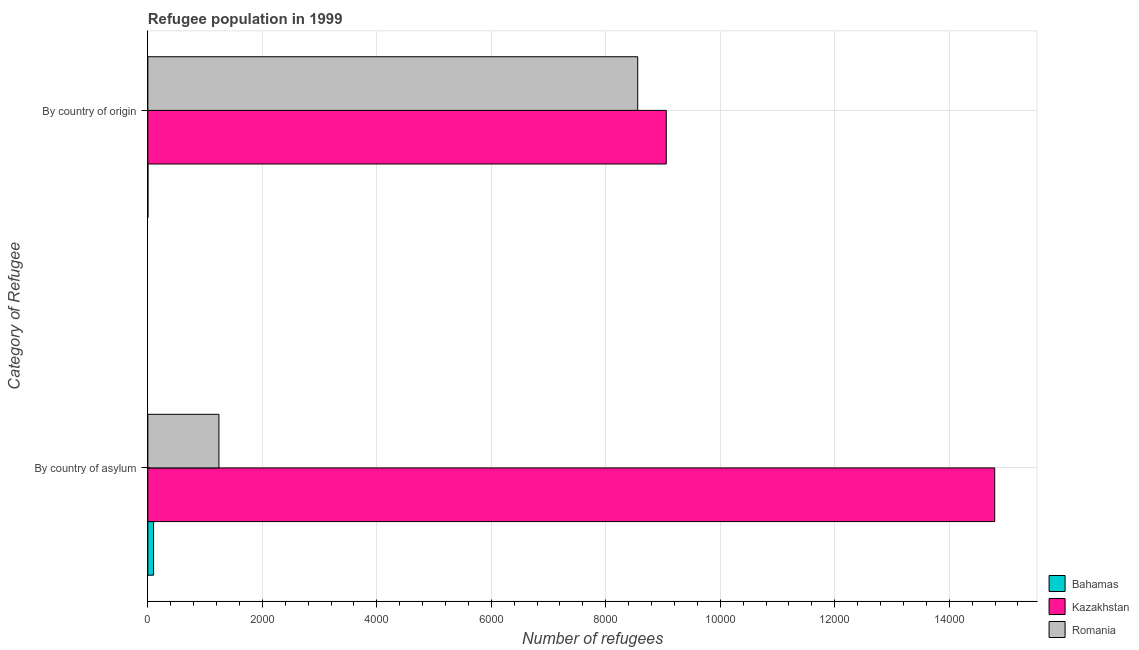How many different coloured bars are there?
Your answer should be very brief. 3. How many groups of bars are there?
Offer a very short reply. 2. Are the number of bars per tick equal to the number of legend labels?
Provide a short and direct response. Yes. Are the number of bars on each tick of the Y-axis equal?
Give a very brief answer. Yes. How many bars are there on the 1st tick from the top?
Your answer should be compact. 3. How many bars are there on the 1st tick from the bottom?
Offer a very short reply. 3. What is the label of the 2nd group of bars from the top?
Give a very brief answer. By country of asylum. What is the number of refugees by country of asylum in Kazakhstan?
Give a very brief answer. 1.48e+04. Across all countries, what is the maximum number of refugees by country of asylum?
Ensure brevity in your answer.  1.48e+04. Across all countries, what is the minimum number of refugees by country of origin?
Make the answer very short. 1. In which country was the number of refugees by country of asylum maximum?
Offer a very short reply. Kazakhstan. In which country was the number of refugees by country of origin minimum?
Your response must be concise. Bahamas. What is the total number of refugees by country of asylum in the graph?
Offer a very short reply. 1.61e+04. What is the difference between the number of refugees by country of asylum in Kazakhstan and that in Bahamas?
Ensure brevity in your answer.  1.47e+04. What is the difference between the number of refugees by country of origin in Kazakhstan and the number of refugees by country of asylum in Romania?
Provide a succinct answer. 7815. What is the average number of refugees by country of origin per country?
Make the answer very short. 5872. What is the difference between the number of refugees by country of asylum and number of refugees by country of origin in Romania?
Provide a succinct answer. -7316. What is the ratio of the number of refugees by country of origin in Bahamas to that in Romania?
Ensure brevity in your answer.  0. Is the number of refugees by country of asylum in Romania less than that in Bahamas?
Make the answer very short. No. In how many countries, is the number of refugees by country of asylum greater than the average number of refugees by country of asylum taken over all countries?
Offer a very short reply. 1. What does the 3rd bar from the top in By country of asylum represents?
Your response must be concise. Bahamas. What does the 2nd bar from the bottom in By country of asylum represents?
Your answer should be compact. Kazakhstan. How many bars are there?
Your answer should be compact. 6. Are the values on the major ticks of X-axis written in scientific E-notation?
Ensure brevity in your answer.  No. Does the graph contain grids?
Ensure brevity in your answer.  Yes. What is the title of the graph?
Your answer should be compact. Refugee population in 1999. What is the label or title of the X-axis?
Ensure brevity in your answer.  Number of refugees. What is the label or title of the Y-axis?
Ensure brevity in your answer.  Category of Refugee. What is the Number of refugees of Bahamas in By country of asylum?
Provide a succinct answer. 100. What is the Number of refugees of Kazakhstan in By country of asylum?
Offer a terse response. 1.48e+04. What is the Number of refugees of Romania in By country of asylum?
Ensure brevity in your answer.  1242. What is the Number of refugees of Bahamas in By country of origin?
Your answer should be compact. 1. What is the Number of refugees of Kazakhstan in By country of origin?
Your answer should be very brief. 9057. What is the Number of refugees of Romania in By country of origin?
Provide a succinct answer. 8558. Across all Category of Refugee, what is the maximum Number of refugees in Kazakhstan?
Your answer should be very brief. 1.48e+04. Across all Category of Refugee, what is the maximum Number of refugees of Romania?
Your answer should be very brief. 8558. Across all Category of Refugee, what is the minimum Number of refugees of Bahamas?
Ensure brevity in your answer.  1. Across all Category of Refugee, what is the minimum Number of refugees of Kazakhstan?
Keep it short and to the point. 9057. Across all Category of Refugee, what is the minimum Number of refugees in Romania?
Provide a succinct answer. 1242. What is the total Number of refugees of Bahamas in the graph?
Keep it short and to the point. 101. What is the total Number of refugees in Kazakhstan in the graph?
Your response must be concise. 2.39e+04. What is the total Number of refugees of Romania in the graph?
Ensure brevity in your answer.  9800. What is the difference between the Number of refugees in Bahamas in By country of asylum and that in By country of origin?
Ensure brevity in your answer.  99. What is the difference between the Number of refugees of Kazakhstan in By country of asylum and that in By country of origin?
Your answer should be very brief. 5738. What is the difference between the Number of refugees of Romania in By country of asylum and that in By country of origin?
Your answer should be very brief. -7316. What is the difference between the Number of refugees in Bahamas in By country of asylum and the Number of refugees in Kazakhstan in By country of origin?
Keep it short and to the point. -8957. What is the difference between the Number of refugees in Bahamas in By country of asylum and the Number of refugees in Romania in By country of origin?
Offer a terse response. -8458. What is the difference between the Number of refugees in Kazakhstan in By country of asylum and the Number of refugees in Romania in By country of origin?
Ensure brevity in your answer.  6237. What is the average Number of refugees in Bahamas per Category of Refugee?
Make the answer very short. 50.5. What is the average Number of refugees of Kazakhstan per Category of Refugee?
Your answer should be compact. 1.19e+04. What is the average Number of refugees in Romania per Category of Refugee?
Provide a succinct answer. 4900. What is the difference between the Number of refugees of Bahamas and Number of refugees of Kazakhstan in By country of asylum?
Offer a terse response. -1.47e+04. What is the difference between the Number of refugees of Bahamas and Number of refugees of Romania in By country of asylum?
Your answer should be compact. -1142. What is the difference between the Number of refugees of Kazakhstan and Number of refugees of Romania in By country of asylum?
Your response must be concise. 1.36e+04. What is the difference between the Number of refugees in Bahamas and Number of refugees in Kazakhstan in By country of origin?
Make the answer very short. -9056. What is the difference between the Number of refugees of Bahamas and Number of refugees of Romania in By country of origin?
Ensure brevity in your answer.  -8557. What is the difference between the Number of refugees of Kazakhstan and Number of refugees of Romania in By country of origin?
Give a very brief answer. 499. What is the ratio of the Number of refugees in Kazakhstan in By country of asylum to that in By country of origin?
Your response must be concise. 1.63. What is the ratio of the Number of refugees in Romania in By country of asylum to that in By country of origin?
Give a very brief answer. 0.15. What is the difference between the highest and the second highest Number of refugees of Bahamas?
Your response must be concise. 99. What is the difference between the highest and the second highest Number of refugees in Kazakhstan?
Your answer should be compact. 5738. What is the difference between the highest and the second highest Number of refugees in Romania?
Your answer should be compact. 7316. What is the difference between the highest and the lowest Number of refugees in Bahamas?
Keep it short and to the point. 99. What is the difference between the highest and the lowest Number of refugees in Kazakhstan?
Your answer should be compact. 5738. What is the difference between the highest and the lowest Number of refugees in Romania?
Keep it short and to the point. 7316. 